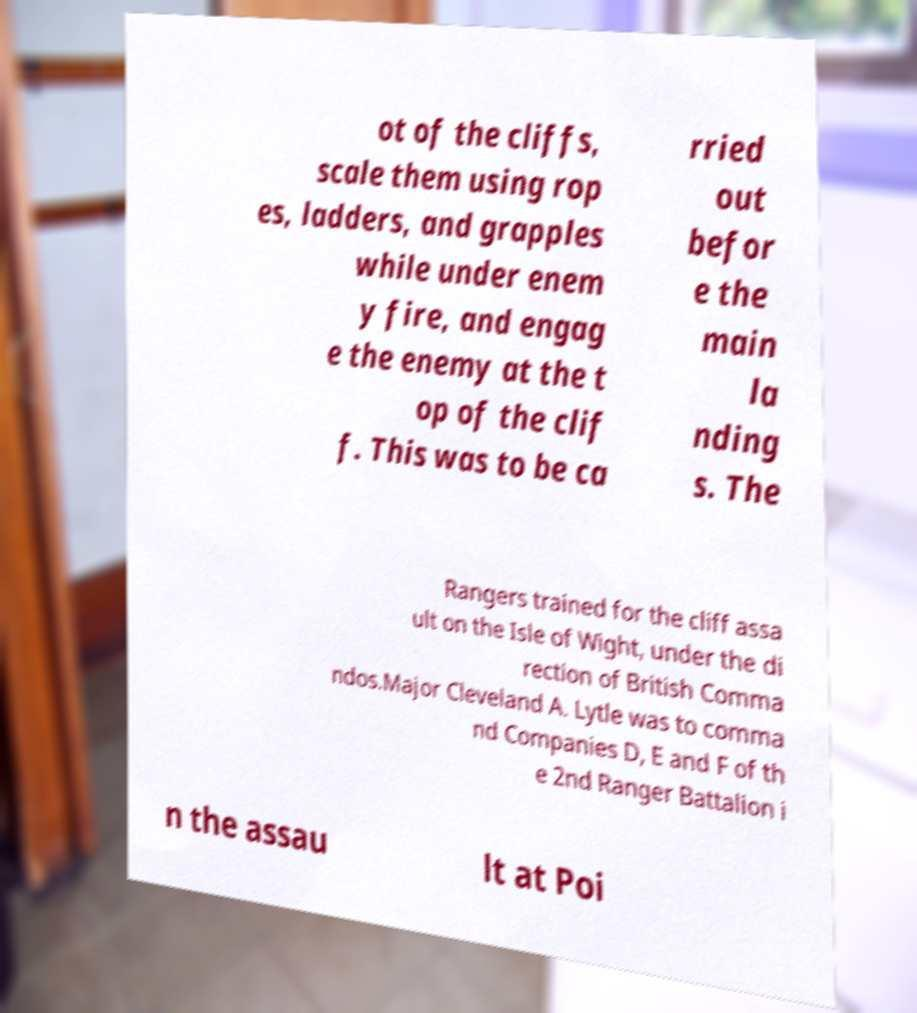Please identify and transcribe the text found in this image. ot of the cliffs, scale them using rop es, ladders, and grapples while under enem y fire, and engag e the enemy at the t op of the clif f. This was to be ca rried out befor e the main la nding s. The Rangers trained for the cliff assa ult on the Isle of Wight, under the di rection of British Comma ndos.Major Cleveland A. Lytle was to comma nd Companies D, E and F of th e 2nd Ranger Battalion i n the assau lt at Poi 